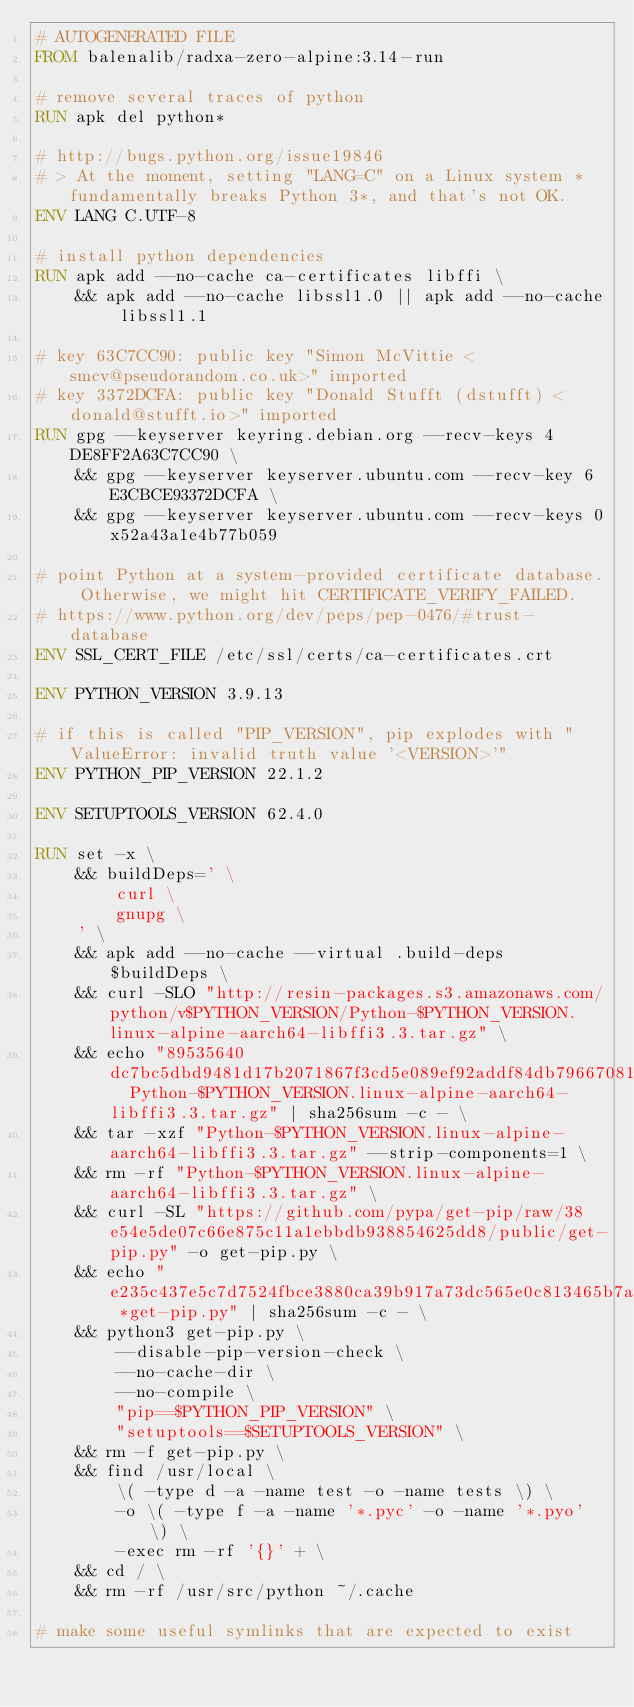<code> <loc_0><loc_0><loc_500><loc_500><_Dockerfile_># AUTOGENERATED FILE
FROM balenalib/radxa-zero-alpine:3.14-run

# remove several traces of python
RUN apk del python*

# http://bugs.python.org/issue19846
# > At the moment, setting "LANG=C" on a Linux system *fundamentally breaks Python 3*, and that's not OK.
ENV LANG C.UTF-8

# install python dependencies
RUN apk add --no-cache ca-certificates libffi \
	&& apk add --no-cache libssl1.0 || apk add --no-cache libssl1.1

# key 63C7CC90: public key "Simon McVittie <smcv@pseudorandom.co.uk>" imported
# key 3372DCFA: public key "Donald Stufft (dstufft) <donald@stufft.io>" imported
RUN gpg --keyserver keyring.debian.org --recv-keys 4DE8FF2A63C7CC90 \
	&& gpg --keyserver keyserver.ubuntu.com --recv-key 6E3CBCE93372DCFA \
	&& gpg --keyserver keyserver.ubuntu.com --recv-keys 0x52a43a1e4b77b059

# point Python at a system-provided certificate database. Otherwise, we might hit CERTIFICATE_VERIFY_FAILED.
# https://www.python.org/dev/peps/pep-0476/#trust-database
ENV SSL_CERT_FILE /etc/ssl/certs/ca-certificates.crt

ENV PYTHON_VERSION 3.9.13

# if this is called "PIP_VERSION", pip explodes with "ValueError: invalid truth value '<VERSION>'"
ENV PYTHON_PIP_VERSION 22.1.2

ENV SETUPTOOLS_VERSION 62.4.0

RUN set -x \
	&& buildDeps=' \
		curl \
		gnupg \
	' \
	&& apk add --no-cache --virtual .build-deps $buildDeps \
	&& curl -SLO "http://resin-packages.s3.amazonaws.com/python/v$PYTHON_VERSION/Python-$PYTHON_VERSION.linux-alpine-aarch64-libffi3.3.tar.gz" \
	&& echo "89535640dc7bc5dbd9481d17b2071867f3cd5e089ef92addf84db79667081d11  Python-$PYTHON_VERSION.linux-alpine-aarch64-libffi3.3.tar.gz" | sha256sum -c - \
	&& tar -xzf "Python-$PYTHON_VERSION.linux-alpine-aarch64-libffi3.3.tar.gz" --strip-components=1 \
	&& rm -rf "Python-$PYTHON_VERSION.linux-alpine-aarch64-libffi3.3.tar.gz" \
	&& curl -SL "https://github.com/pypa/get-pip/raw/38e54e5de07c66e875c11a1ebbdb938854625dd8/public/get-pip.py" -o get-pip.py \
    && echo "e235c437e5c7d7524fbce3880ca39b917a73dc565e0c813465b7a7a329bb279a *get-pip.py" | sha256sum -c - \
    && python3 get-pip.py \
        --disable-pip-version-check \
        --no-cache-dir \
        --no-compile \
        "pip==$PYTHON_PIP_VERSION" \
        "setuptools==$SETUPTOOLS_VERSION" \
	&& rm -f get-pip.py \
	&& find /usr/local \
		\( -type d -a -name test -o -name tests \) \
		-o \( -type f -a -name '*.pyc' -o -name '*.pyo' \) \
		-exec rm -rf '{}' + \
	&& cd / \
	&& rm -rf /usr/src/python ~/.cache

# make some useful symlinks that are expected to exist</code> 